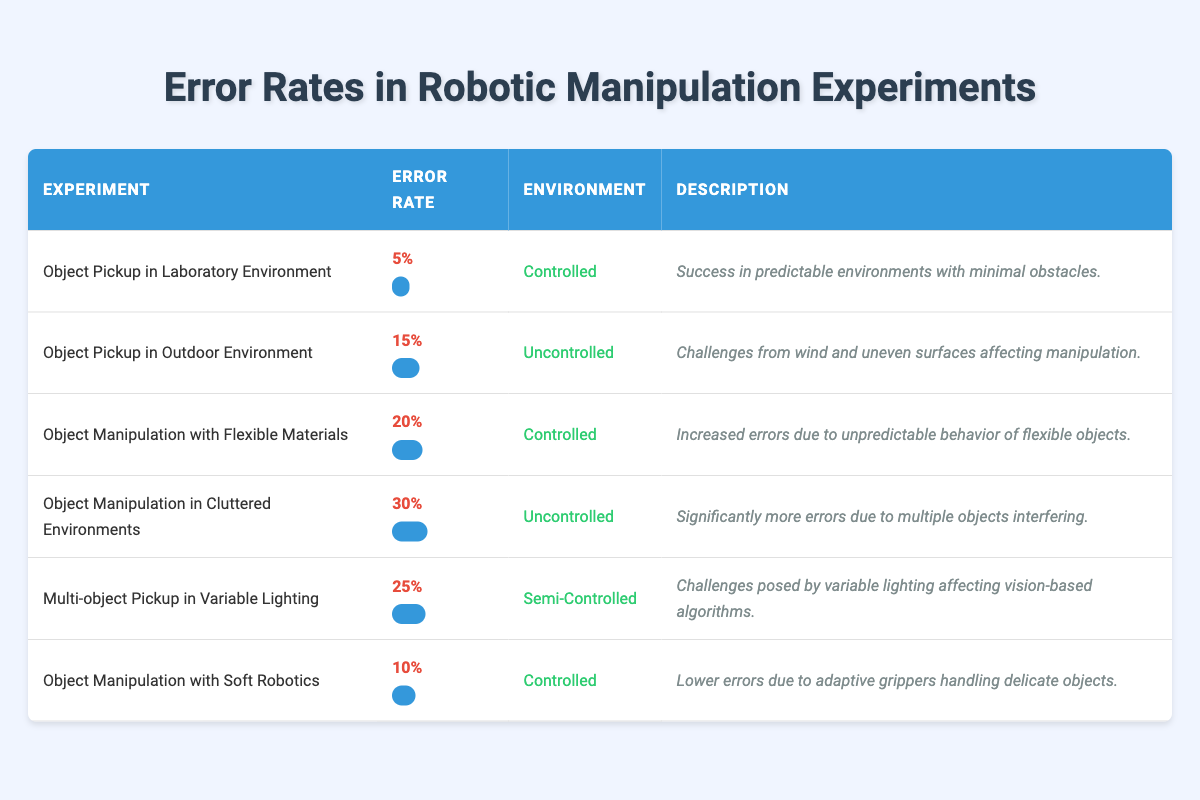What is the error rate for "Object Pickup in Laboratory Environment"? According to the table, the error rate for this experiment is specifically listed as 0.05, which represents 5%.
Answer: 5% Which experiment has the highest error rate? By examining the error rates in the table, "Object Manipulation in Cluttered Environments" has the highest error rate at 0.30, which is 30%.
Answer: 30% What is the error rate difference between "Object Pickup in Outdoor Environment" and "Object Manipulation with Soft Robotics"? The error rate for "Object Pickup in Outdoor Environment" is 15% (0.15), while for "Object Manipulation with Soft Robotics," it is 10% (0.10). The difference between these two rates is 15% - 10% = 5%.
Answer: 5% Is it true that all experiments conducted in controlled environments have lower error rates than those in uncontrolled environments? Yes, upon reviewing the table, all experiments labeled as controlled have error rates of 5%, 20%, and 10%, while uncontrolled environments show rates of 15% and 30%. Hence, it is true that controlled environments show lower error rates.
Answer: Yes What is the average error rate for all the experiments listed? To calculate the average, first sum the error rates: 0.05 + 0.15 + 0.20 + 0.30 + 0.25 + 0.10 = 1.05. Next, divide by the number of experiments, which is 6: 1.05 / 6 = 0.175 or 17.5%.
Answer: 17.5% Which environment type has the highest average error rate? To find this, calculate the average error rate for each environment type: Controlled (0.05 + 0.20 + 0.10) / 3 = 0.1167; Uncontrolled (0.15 + 0.30) / 2 = 0.225; Semi-controlled (0.25) = 0.25. The highest average is for the uncontrolled environment at 0.225.
Answer: Uncontrolled 